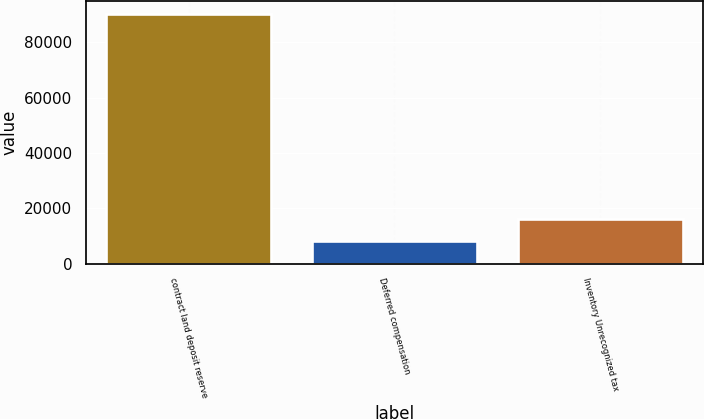Convert chart. <chart><loc_0><loc_0><loc_500><loc_500><bar_chart><fcel>contract land deposit reserve<fcel>Deferred compensation<fcel>Inventory Unrecognized tax<nl><fcel>90372<fcel>8049<fcel>16281.3<nl></chart> 